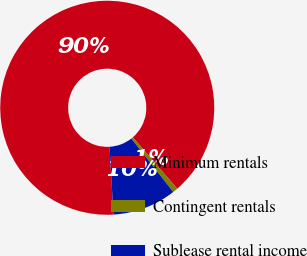Convert chart. <chart><loc_0><loc_0><loc_500><loc_500><pie_chart><fcel>Minimum rentals<fcel>Contingent rentals<fcel>Sublease rental income<nl><fcel>89.59%<fcel>0.77%<fcel>9.65%<nl></chart> 